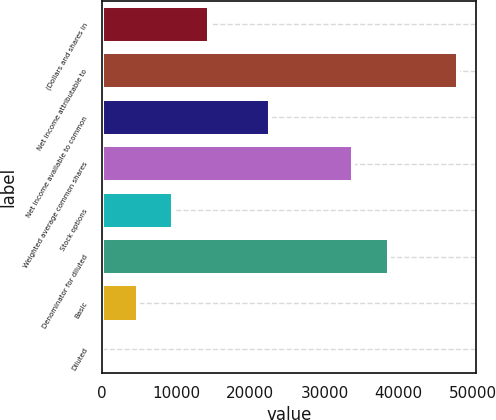Convert chart. <chart><loc_0><loc_0><loc_500><loc_500><bar_chart><fcel>(Dollars and shares in<fcel>Net income attributable to<fcel>Net income available to common<fcel>Weighted average common shares<fcel>Stock options<fcel>Denominator for diluted<fcel>Basic<fcel>Diluted<nl><fcel>14403.5<fcel>48010<fcel>22674<fcel>33901<fcel>9602.52<fcel>38701.9<fcel>4801.59<fcel>0.66<nl></chart> 